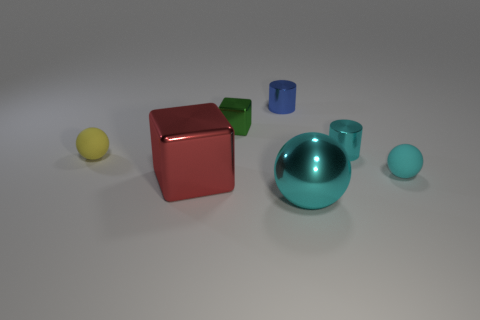There is a cyan thing that is to the left of the cyan cylinder; what is its material?
Ensure brevity in your answer.  Metal. There is a ball that is both behind the metallic sphere and right of the small green metallic cube; what is its color?
Keep it short and to the point. Cyan. What number of other objects are there of the same color as the small metal cube?
Keep it short and to the point. 0. What is the color of the thing that is left of the large shiny cube?
Give a very brief answer. Yellow. Are there any blue objects that have the same size as the blue metal cylinder?
Keep it short and to the point. No. There is a green thing that is the same size as the yellow ball; what material is it?
Your response must be concise. Metal. How many objects are blocks that are in front of the small cyan sphere or objects in front of the tiny cyan metal cylinder?
Give a very brief answer. 4. Is there a tiny cyan matte object of the same shape as the red metal object?
Your answer should be very brief. No. There is a cylinder that is the same color as the large metallic ball; what is it made of?
Your answer should be compact. Metal. How many metal things are large purple cubes or cyan objects?
Offer a very short reply. 2. 